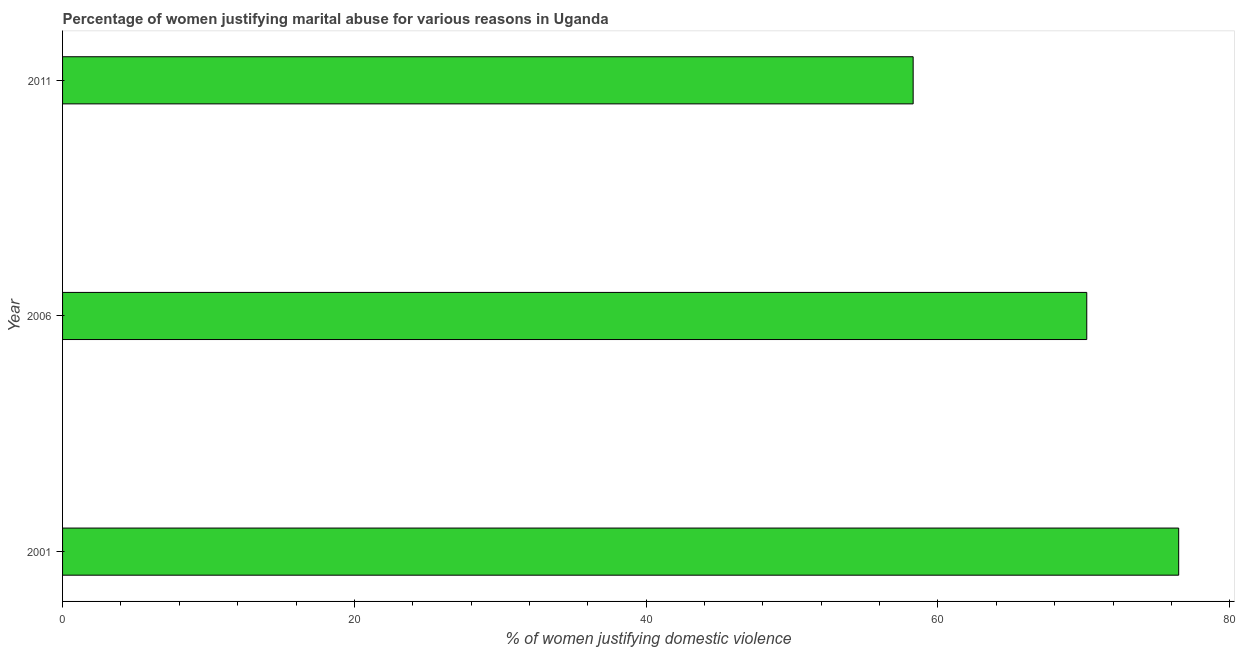Does the graph contain grids?
Keep it short and to the point. No. What is the title of the graph?
Ensure brevity in your answer.  Percentage of women justifying marital abuse for various reasons in Uganda. What is the label or title of the X-axis?
Your answer should be very brief. % of women justifying domestic violence. What is the label or title of the Y-axis?
Your answer should be compact. Year. What is the percentage of women justifying marital abuse in 2001?
Keep it short and to the point. 76.5. Across all years, what is the maximum percentage of women justifying marital abuse?
Provide a short and direct response. 76.5. Across all years, what is the minimum percentage of women justifying marital abuse?
Provide a succinct answer. 58.3. In which year was the percentage of women justifying marital abuse maximum?
Keep it short and to the point. 2001. In which year was the percentage of women justifying marital abuse minimum?
Offer a very short reply. 2011. What is the sum of the percentage of women justifying marital abuse?
Provide a short and direct response. 205. What is the difference between the percentage of women justifying marital abuse in 2006 and 2011?
Offer a very short reply. 11.9. What is the average percentage of women justifying marital abuse per year?
Provide a short and direct response. 68.33. What is the median percentage of women justifying marital abuse?
Provide a succinct answer. 70.2. In how many years, is the percentage of women justifying marital abuse greater than 68 %?
Offer a terse response. 2. Do a majority of the years between 2001 and 2006 (inclusive) have percentage of women justifying marital abuse greater than 40 %?
Ensure brevity in your answer.  Yes. What is the ratio of the percentage of women justifying marital abuse in 2006 to that in 2011?
Keep it short and to the point. 1.2. What is the difference between the highest and the second highest percentage of women justifying marital abuse?
Keep it short and to the point. 6.3. Is the sum of the percentage of women justifying marital abuse in 2001 and 2006 greater than the maximum percentage of women justifying marital abuse across all years?
Your response must be concise. Yes. What is the difference between the highest and the lowest percentage of women justifying marital abuse?
Your response must be concise. 18.2. How many bars are there?
Ensure brevity in your answer.  3. Are all the bars in the graph horizontal?
Provide a succinct answer. Yes. What is the difference between two consecutive major ticks on the X-axis?
Provide a succinct answer. 20. Are the values on the major ticks of X-axis written in scientific E-notation?
Keep it short and to the point. No. What is the % of women justifying domestic violence in 2001?
Your response must be concise. 76.5. What is the % of women justifying domestic violence in 2006?
Your answer should be compact. 70.2. What is the % of women justifying domestic violence in 2011?
Your response must be concise. 58.3. What is the difference between the % of women justifying domestic violence in 2006 and 2011?
Make the answer very short. 11.9. What is the ratio of the % of women justifying domestic violence in 2001 to that in 2006?
Provide a succinct answer. 1.09. What is the ratio of the % of women justifying domestic violence in 2001 to that in 2011?
Your response must be concise. 1.31. What is the ratio of the % of women justifying domestic violence in 2006 to that in 2011?
Provide a succinct answer. 1.2. 